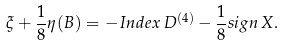<formula> <loc_0><loc_0><loc_500><loc_500>\xi + \frac { 1 } { 8 } \eta ( B ) = - I n d e x \, D ^ { ( 4 ) } - \frac { 1 } { 8 } s i g n \, X .</formula> 